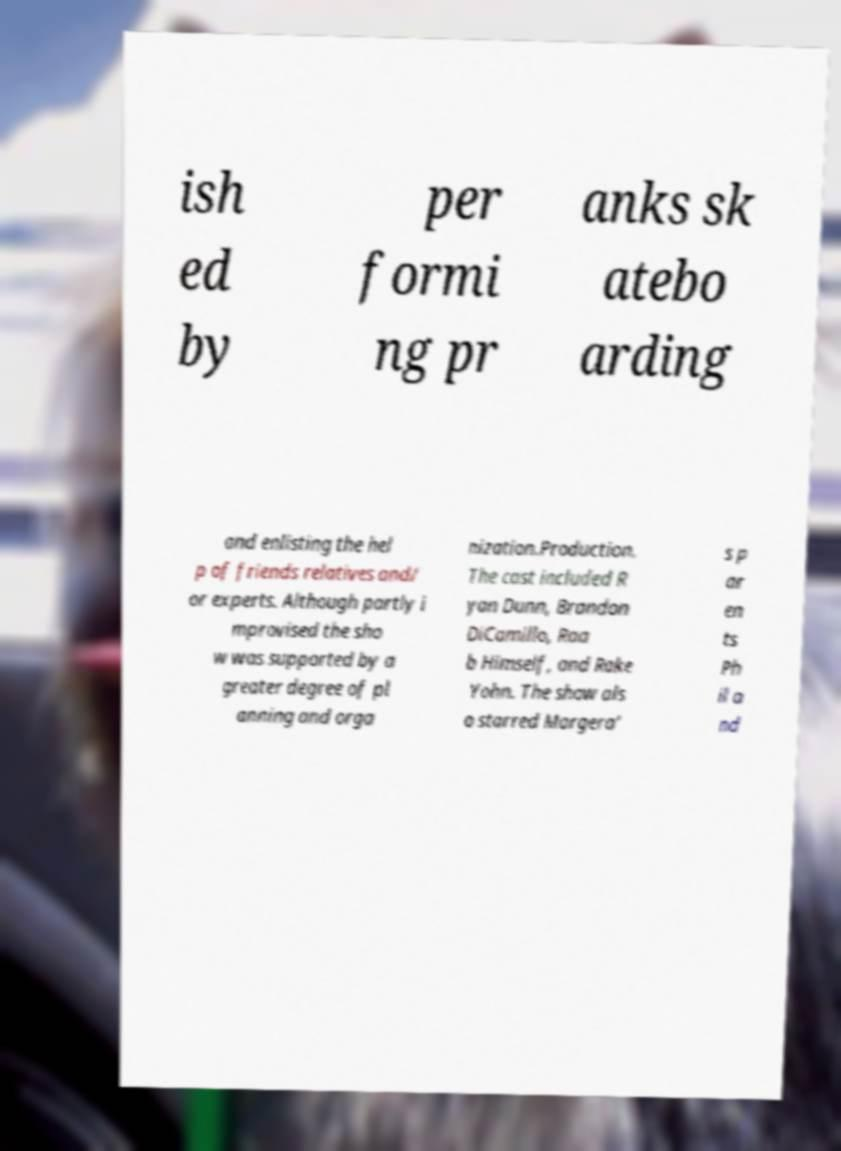Could you assist in decoding the text presented in this image and type it out clearly? ish ed by per formi ng pr anks sk atebo arding and enlisting the hel p of friends relatives and/ or experts. Although partly i mprovised the sho w was supported by a greater degree of pl anning and orga nization.Production. The cast included R yan Dunn, Brandon DiCamillo, Raa b Himself, and Rake Yohn. The show als o starred Margera' s p ar en ts Ph il a nd 